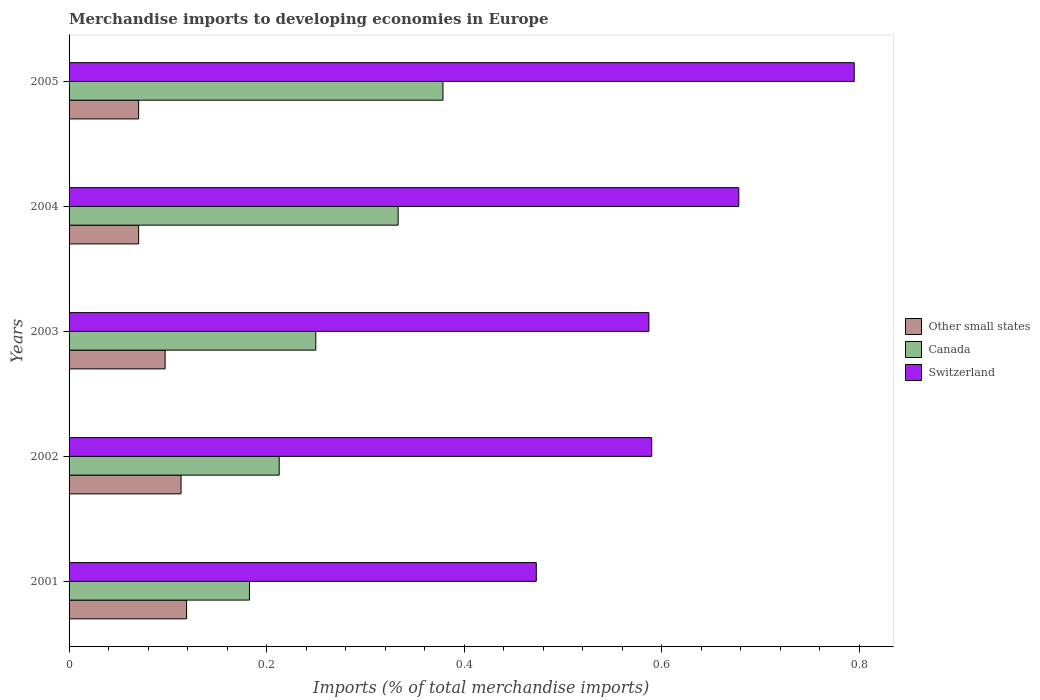How many different coloured bars are there?
Provide a short and direct response. 3. How many groups of bars are there?
Your answer should be compact. 5. How many bars are there on the 3rd tick from the top?
Offer a terse response. 3. What is the percentage total merchandise imports in Canada in 2003?
Provide a short and direct response. 0.25. Across all years, what is the maximum percentage total merchandise imports in Other small states?
Your response must be concise. 0.12. Across all years, what is the minimum percentage total merchandise imports in Switzerland?
Keep it short and to the point. 0.47. What is the total percentage total merchandise imports in Switzerland in the graph?
Give a very brief answer. 3.12. What is the difference between the percentage total merchandise imports in Canada in 2002 and that in 2004?
Give a very brief answer. -0.12. What is the difference between the percentage total merchandise imports in Other small states in 2001 and the percentage total merchandise imports in Switzerland in 2002?
Offer a terse response. -0.47. What is the average percentage total merchandise imports in Canada per year?
Provide a succinct answer. 0.27. In the year 2004, what is the difference between the percentage total merchandise imports in Switzerland and percentage total merchandise imports in Canada?
Your response must be concise. 0.34. In how many years, is the percentage total merchandise imports in Canada greater than 0.16 %?
Your response must be concise. 5. What is the ratio of the percentage total merchandise imports in Switzerland in 2002 to that in 2005?
Your answer should be compact. 0.74. What is the difference between the highest and the second highest percentage total merchandise imports in Other small states?
Give a very brief answer. 0.01. What is the difference between the highest and the lowest percentage total merchandise imports in Canada?
Make the answer very short. 0.2. In how many years, is the percentage total merchandise imports in Other small states greater than the average percentage total merchandise imports in Other small states taken over all years?
Offer a very short reply. 3. Is the sum of the percentage total merchandise imports in Switzerland in 2002 and 2003 greater than the maximum percentage total merchandise imports in Other small states across all years?
Offer a very short reply. Yes. What does the 1st bar from the top in 2003 represents?
Keep it short and to the point. Switzerland. Is it the case that in every year, the sum of the percentage total merchandise imports in Switzerland and percentage total merchandise imports in Canada is greater than the percentage total merchandise imports in Other small states?
Provide a short and direct response. Yes. Are all the bars in the graph horizontal?
Ensure brevity in your answer.  Yes. Does the graph contain any zero values?
Your answer should be very brief. No. Does the graph contain grids?
Ensure brevity in your answer.  No. Where does the legend appear in the graph?
Provide a succinct answer. Center right. How many legend labels are there?
Your answer should be very brief. 3. What is the title of the graph?
Keep it short and to the point. Merchandise imports to developing economies in Europe. Does "Jamaica" appear as one of the legend labels in the graph?
Give a very brief answer. No. What is the label or title of the X-axis?
Ensure brevity in your answer.  Imports (% of total merchandise imports). What is the Imports (% of total merchandise imports) in Other small states in 2001?
Keep it short and to the point. 0.12. What is the Imports (% of total merchandise imports) in Canada in 2001?
Offer a very short reply. 0.18. What is the Imports (% of total merchandise imports) of Switzerland in 2001?
Ensure brevity in your answer.  0.47. What is the Imports (% of total merchandise imports) in Other small states in 2002?
Offer a very short reply. 0.11. What is the Imports (% of total merchandise imports) in Canada in 2002?
Give a very brief answer. 0.21. What is the Imports (% of total merchandise imports) of Switzerland in 2002?
Ensure brevity in your answer.  0.59. What is the Imports (% of total merchandise imports) in Other small states in 2003?
Make the answer very short. 0.1. What is the Imports (% of total merchandise imports) of Canada in 2003?
Offer a very short reply. 0.25. What is the Imports (% of total merchandise imports) of Switzerland in 2003?
Ensure brevity in your answer.  0.59. What is the Imports (% of total merchandise imports) of Other small states in 2004?
Your answer should be very brief. 0.07. What is the Imports (% of total merchandise imports) in Canada in 2004?
Offer a terse response. 0.33. What is the Imports (% of total merchandise imports) of Switzerland in 2004?
Ensure brevity in your answer.  0.68. What is the Imports (% of total merchandise imports) of Other small states in 2005?
Ensure brevity in your answer.  0.07. What is the Imports (% of total merchandise imports) in Canada in 2005?
Your response must be concise. 0.38. What is the Imports (% of total merchandise imports) in Switzerland in 2005?
Make the answer very short. 0.79. Across all years, what is the maximum Imports (% of total merchandise imports) in Other small states?
Your response must be concise. 0.12. Across all years, what is the maximum Imports (% of total merchandise imports) in Canada?
Offer a very short reply. 0.38. Across all years, what is the maximum Imports (% of total merchandise imports) of Switzerland?
Ensure brevity in your answer.  0.79. Across all years, what is the minimum Imports (% of total merchandise imports) in Other small states?
Your response must be concise. 0.07. Across all years, what is the minimum Imports (% of total merchandise imports) of Canada?
Give a very brief answer. 0.18. Across all years, what is the minimum Imports (% of total merchandise imports) of Switzerland?
Your answer should be compact. 0.47. What is the total Imports (% of total merchandise imports) in Other small states in the graph?
Offer a terse response. 0.47. What is the total Imports (% of total merchandise imports) in Canada in the graph?
Make the answer very short. 1.36. What is the total Imports (% of total merchandise imports) of Switzerland in the graph?
Keep it short and to the point. 3.12. What is the difference between the Imports (% of total merchandise imports) of Other small states in 2001 and that in 2002?
Make the answer very short. 0.01. What is the difference between the Imports (% of total merchandise imports) in Canada in 2001 and that in 2002?
Keep it short and to the point. -0.03. What is the difference between the Imports (% of total merchandise imports) of Switzerland in 2001 and that in 2002?
Your response must be concise. -0.12. What is the difference between the Imports (% of total merchandise imports) of Other small states in 2001 and that in 2003?
Ensure brevity in your answer.  0.02. What is the difference between the Imports (% of total merchandise imports) in Canada in 2001 and that in 2003?
Provide a succinct answer. -0.07. What is the difference between the Imports (% of total merchandise imports) of Switzerland in 2001 and that in 2003?
Offer a very short reply. -0.11. What is the difference between the Imports (% of total merchandise imports) of Other small states in 2001 and that in 2004?
Make the answer very short. 0.05. What is the difference between the Imports (% of total merchandise imports) in Canada in 2001 and that in 2004?
Provide a succinct answer. -0.15. What is the difference between the Imports (% of total merchandise imports) of Switzerland in 2001 and that in 2004?
Keep it short and to the point. -0.2. What is the difference between the Imports (% of total merchandise imports) of Other small states in 2001 and that in 2005?
Offer a terse response. 0.05. What is the difference between the Imports (% of total merchandise imports) in Canada in 2001 and that in 2005?
Provide a short and direct response. -0.2. What is the difference between the Imports (% of total merchandise imports) of Switzerland in 2001 and that in 2005?
Keep it short and to the point. -0.32. What is the difference between the Imports (% of total merchandise imports) in Other small states in 2002 and that in 2003?
Your answer should be very brief. 0.02. What is the difference between the Imports (% of total merchandise imports) of Canada in 2002 and that in 2003?
Provide a succinct answer. -0.04. What is the difference between the Imports (% of total merchandise imports) of Switzerland in 2002 and that in 2003?
Provide a succinct answer. 0. What is the difference between the Imports (% of total merchandise imports) of Other small states in 2002 and that in 2004?
Your response must be concise. 0.04. What is the difference between the Imports (% of total merchandise imports) in Canada in 2002 and that in 2004?
Provide a short and direct response. -0.12. What is the difference between the Imports (% of total merchandise imports) of Switzerland in 2002 and that in 2004?
Provide a succinct answer. -0.09. What is the difference between the Imports (% of total merchandise imports) of Other small states in 2002 and that in 2005?
Ensure brevity in your answer.  0.04. What is the difference between the Imports (% of total merchandise imports) of Canada in 2002 and that in 2005?
Your response must be concise. -0.17. What is the difference between the Imports (% of total merchandise imports) of Switzerland in 2002 and that in 2005?
Give a very brief answer. -0.2. What is the difference between the Imports (% of total merchandise imports) of Other small states in 2003 and that in 2004?
Ensure brevity in your answer.  0.03. What is the difference between the Imports (% of total merchandise imports) of Canada in 2003 and that in 2004?
Provide a succinct answer. -0.08. What is the difference between the Imports (% of total merchandise imports) of Switzerland in 2003 and that in 2004?
Provide a succinct answer. -0.09. What is the difference between the Imports (% of total merchandise imports) of Other small states in 2003 and that in 2005?
Offer a very short reply. 0.03. What is the difference between the Imports (% of total merchandise imports) of Canada in 2003 and that in 2005?
Your answer should be very brief. -0.13. What is the difference between the Imports (% of total merchandise imports) in Switzerland in 2003 and that in 2005?
Offer a terse response. -0.21. What is the difference between the Imports (% of total merchandise imports) in Canada in 2004 and that in 2005?
Make the answer very short. -0.05. What is the difference between the Imports (% of total merchandise imports) of Switzerland in 2004 and that in 2005?
Your response must be concise. -0.12. What is the difference between the Imports (% of total merchandise imports) of Other small states in 2001 and the Imports (% of total merchandise imports) of Canada in 2002?
Provide a short and direct response. -0.09. What is the difference between the Imports (% of total merchandise imports) in Other small states in 2001 and the Imports (% of total merchandise imports) in Switzerland in 2002?
Provide a succinct answer. -0.47. What is the difference between the Imports (% of total merchandise imports) of Canada in 2001 and the Imports (% of total merchandise imports) of Switzerland in 2002?
Your response must be concise. -0.41. What is the difference between the Imports (% of total merchandise imports) in Other small states in 2001 and the Imports (% of total merchandise imports) in Canada in 2003?
Provide a succinct answer. -0.13. What is the difference between the Imports (% of total merchandise imports) in Other small states in 2001 and the Imports (% of total merchandise imports) in Switzerland in 2003?
Keep it short and to the point. -0.47. What is the difference between the Imports (% of total merchandise imports) of Canada in 2001 and the Imports (% of total merchandise imports) of Switzerland in 2003?
Give a very brief answer. -0.4. What is the difference between the Imports (% of total merchandise imports) in Other small states in 2001 and the Imports (% of total merchandise imports) in Canada in 2004?
Provide a short and direct response. -0.21. What is the difference between the Imports (% of total merchandise imports) of Other small states in 2001 and the Imports (% of total merchandise imports) of Switzerland in 2004?
Your response must be concise. -0.56. What is the difference between the Imports (% of total merchandise imports) in Canada in 2001 and the Imports (% of total merchandise imports) in Switzerland in 2004?
Offer a very short reply. -0.5. What is the difference between the Imports (% of total merchandise imports) of Other small states in 2001 and the Imports (% of total merchandise imports) of Canada in 2005?
Keep it short and to the point. -0.26. What is the difference between the Imports (% of total merchandise imports) in Other small states in 2001 and the Imports (% of total merchandise imports) in Switzerland in 2005?
Your answer should be compact. -0.68. What is the difference between the Imports (% of total merchandise imports) in Canada in 2001 and the Imports (% of total merchandise imports) in Switzerland in 2005?
Your answer should be compact. -0.61. What is the difference between the Imports (% of total merchandise imports) in Other small states in 2002 and the Imports (% of total merchandise imports) in Canada in 2003?
Keep it short and to the point. -0.14. What is the difference between the Imports (% of total merchandise imports) in Other small states in 2002 and the Imports (% of total merchandise imports) in Switzerland in 2003?
Offer a terse response. -0.47. What is the difference between the Imports (% of total merchandise imports) of Canada in 2002 and the Imports (% of total merchandise imports) of Switzerland in 2003?
Offer a very short reply. -0.37. What is the difference between the Imports (% of total merchandise imports) in Other small states in 2002 and the Imports (% of total merchandise imports) in Canada in 2004?
Offer a very short reply. -0.22. What is the difference between the Imports (% of total merchandise imports) in Other small states in 2002 and the Imports (% of total merchandise imports) in Switzerland in 2004?
Ensure brevity in your answer.  -0.56. What is the difference between the Imports (% of total merchandise imports) of Canada in 2002 and the Imports (% of total merchandise imports) of Switzerland in 2004?
Provide a short and direct response. -0.47. What is the difference between the Imports (% of total merchandise imports) of Other small states in 2002 and the Imports (% of total merchandise imports) of Canada in 2005?
Your answer should be compact. -0.27. What is the difference between the Imports (% of total merchandise imports) in Other small states in 2002 and the Imports (% of total merchandise imports) in Switzerland in 2005?
Provide a succinct answer. -0.68. What is the difference between the Imports (% of total merchandise imports) of Canada in 2002 and the Imports (% of total merchandise imports) of Switzerland in 2005?
Your response must be concise. -0.58. What is the difference between the Imports (% of total merchandise imports) in Other small states in 2003 and the Imports (% of total merchandise imports) in Canada in 2004?
Your response must be concise. -0.24. What is the difference between the Imports (% of total merchandise imports) in Other small states in 2003 and the Imports (% of total merchandise imports) in Switzerland in 2004?
Ensure brevity in your answer.  -0.58. What is the difference between the Imports (% of total merchandise imports) of Canada in 2003 and the Imports (% of total merchandise imports) of Switzerland in 2004?
Your answer should be compact. -0.43. What is the difference between the Imports (% of total merchandise imports) of Other small states in 2003 and the Imports (% of total merchandise imports) of Canada in 2005?
Provide a succinct answer. -0.28. What is the difference between the Imports (% of total merchandise imports) in Other small states in 2003 and the Imports (% of total merchandise imports) in Switzerland in 2005?
Your response must be concise. -0.7. What is the difference between the Imports (% of total merchandise imports) of Canada in 2003 and the Imports (% of total merchandise imports) of Switzerland in 2005?
Offer a very short reply. -0.55. What is the difference between the Imports (% of total merchandise imports) of Other small states in 2004 and the Imports (% of total merchandise imports) of Canada in 2005?
Ensure brevity in your answer.  -0.31. What is the difference between the Imports (% of total merchandise imports) of Other small states in 2004 and the Imports (% of total merchandise imports) of Switzerland in 2005?
Ensure brevity in your answer.  -0.72. What is the difference between the Imports (% of total merchandise imports) in Canada in 2004 and the Imports (% of total merchandise imports) in Switzerland in 2005?
Offer a terse response. -0.46. What is the average Imports (% of total merchandise imports) in Other small states per year?
Make the answer very short. 0.09. What is the average Imports (% of total merchandise imports) in Canada per year?
Offer a terse response. 0.27. What is the average Imports (% of total merchandise imports) in Switzerland per year?
Offer a very short reply. 0.62. In the year 2001, what is the difference between the Imports (% of total merchandise imports) of Other small states and Imports (% of total merchandise imports) of Canada?
Your response must be concise. -0.06. In the year 2001, what is the difference between the Imports (% of total merchandise imports) in Other small states and Imports (% of total merchandise imports) in Switzerland?
Make the answer very short. -0.35. In the year 2001, what is the difference between the Imports (% of total merchandise imports) of Canada and Imports (% of total merchandise imports) of Switzerland?
Give a very brief answer. -0.29. In the year 2002, what is the difference between the Imports (% of total merchandise imports) of Other small states and Imports (% of total merchandise imports) of Canada?
Your answer should be very brief. -0.1. In the year 2002, what is the difference between the Imports (% of total merchandise imports) in Other small states and Imports (% of total merchandise imports) in Switzerland?
Your response must be concise. -0.48. In the year 2002, what is the difference between the Imports (% of total merchandise imports) in Canada and Imports (% of total merchandise imports) in Switzerland?
Offer a very short reply. -0.38. In the year 2003, what is the difference between the Imports (% of total merchandise imports) of Other small states and Imports (% of total merchandise imports) of Canada?
Your response must be concise. -0.15. In the year 2003, what is the difference between the Imports (% of total merchandise imports) in Other small states and Imports (% of total merchandise imports) in Switzerland?
Offer a terse response. -0.49. In the year 2003, what is the difference between the Imports (% of total merchandise imports) of Canada and Imports (% of total merchandise imports) of Switzerland?
Provide a succinct answer. -0.34. In the year 2004, what is the difference between the Imports (% of total merchandise imports) of Other small states and Imports (% of total merchandise imports) of Canada?
Your answer should be compact. -0.26. In the year 2004, what is the difference between the Imports (% of total merchandise imports) of Other small states and Imports (% of total merchandise imports) of Switzerland?
Provide a short and direct response. -0.61. In the year 2004, what is the difference between the Imports (% of total merchandise imports) in Canada and Imports (% of total merchandise imports) in Switzerland?
Give a very brief answer. -0.34. In the year 2005, what is the difference between the Imports (% of total merchandise imports) of Other small states and Imports (% of total merchandise imports) of Canada?
Your answer should be compact. -0.31. In the year 2005, what is the difference between the Imports (% of total merchandise imports) in Other small states and Imports (% of total merchandise imports) in Switzerland?
Your answer should be very brief. -0.72. In the year 2005, what is the difference between the Imports (% of total merchandise imports) of Canada and Imports (% of total merchandise imports) of Switzerland?
Keep it short and to the point. -0.42. What is the ratio of the Imports (% of total merchandise imports) in Other small states in 2001 to that in 2002?
Ensure brevity in your answer.  1.05. What is the ratio of the Imports (% of total merchandise imports) of Canada in 2001 to that in 2002?
Keep it short and to the point. 0.86. What is the ratio of the Imports (% of total merchandise imports) of Switzerland in 2001 to that in 2002?
Keep it short and to the point. 0.8. What is the ratio of the Imports (% of total merchandise imports) in Other small states in 2001 to that in 2003?
Provide a short and direct response. 1.22. What is the ratio of the Imports (% of total merchandise imports) of Canada in 2001 to that in 2003?
Offer a terse response. 0.73. What is the ratio of the Imports (% of total merchandise imports) in Switzerland in 2001 to that in 2003?
Provide a short and direct response. 0.81. What is the ratio of the Imports (% of total merchandise imports) in Other small states in 2001 to that in 2004?
Make the answer very short. 1.69. What is the ratio of the Imports (% of total merchandise imports) in Canada in 2001 to that in 2004?
Keep it short and to the point. 0.55. What is the ratio of the Imports (% of total merchandise imports) in Switzerland in 2001 to that in 2004?
Your response must be concise. 0.7. What is the ratio of the Imports (% of total merchandise imports) in Other small states in 2001 to that in 2005?
Keep it short and to the point. 1.69. What is the ratio of the Imports (% of total merchandise imports) of Canada in 2001 to that in 2005?
Your answer should be very brief. 0.48. What is the ratio of the Imports (% of total merchandise imports) in Switzerland in 2001 to that in 2005?
Provide a succinct answer. 0.6. What is the ratio of the Imports (% of total merchandise imports) of Other small states in 2002 to that in 2003?
Ensure brevity in your answer.  1.17. What is the ratio of the Imports (% of total merchandise imports) of Canada in 2002 to that in 2003?
Your response must be concise. 0.85. What is the ratio of the Imports (% of total merchandise imports) of Switzerland in 2002 to that in 2003?
Keep it short and to the point. 1. What is the ratio of the Imports (% of total merchandise imports) of Other small states in 2002 to that in 2004?
Offer a very short reply. 1.61. What is the ratio of the Imports (% of total merchandise imports) of Canada in 2002 to that in 2004?
Offer a terse response. 0.64. What is the ratio of the Imports (% of total merchandise imports) in Switzerland in 2002 to that in 2004?
Provide a short and direct response. 0.87. What is the ratio of the Imports (% of total merchandise imports) of Other small states in 2002 to that in 2005?
Offer a very short reply. 1.61. What is the ratio of the Imports (% of total merchandise imports) in Canada in 2002 to that in 2005?
Offer a terse response. 0.56. What is the ratio of the Imports (% of total merchandise imports) of Switzerland in 2002 to that in 2005?
Your answer should be very brief. 0.74. What is the ratio of the Imports (% of total merchandise imports) in Other small states in 2003 to that in 2004?
Give a very brief answer. 1.38. What is the ratio of the Imports (% of total merchandise imports) of Canada in 2003 to that in 2004?
Provide a short and direct response. 0.75. What is the ratio of the Imports (% of total merchandise imports) in Switzerland in 2003 to that in 2004?
Your answer should be compact. 0.87. What is the ratio of the Imports (% of total merchandise imports) in Other small states in 2003 to that in 2005?
Ensure brevity in your answer.  1.38. What is the ratio of the Imports (% of total merchandise imports) in Canada in 2003 to that in 2005?
Give a very brief answer. 0.66. What is the ratio of the Imports (% of total merchandise imports) in Switzerland in 2003 to that in 2005?
Your response must be concise. 0.74. What is the ratio of the Imports (% of total merchandise imports) in Canada in 2004 to that in 2005?
Offer a very short reply. 0.88. What is the ratio of the Imports (% of total merchandise imports) of Switzerland in 2004 to that in 2005?
Ensure brevity in your answer.  0.85. What is the difference between the highest and the second highest Imports (% of total merchandise imports) of Other small states?
Offer a very short reply. 0.01. What is the difference between the highest and the second highest Imports (% of total merchandise imports) of Canada?
Offer a terse response. 0.05. What is the difference between the highest and the second highest Imports (% of total merchandise imports) in Switzerland?
Offer a very short reply. 0.12. What is the difference between the highest and the lowest Imports (% of total merchandise imports) in Other small states?
Ensure brevity in your answer.  0.05. What is the difference between the highest and the lowest Imports (% of total merchandise imports) in Canada?
Ensure brevity in your answer.  0.2. What is the difference between the highest and the lowest Imports (% of total merchandise imports) of Switzerland?
Give a very brief answer. 0.32. 